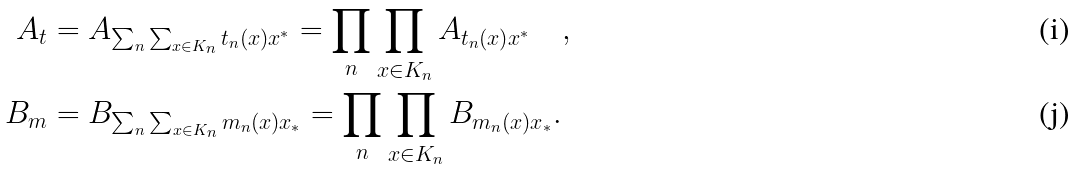Convert formula to latex. <formula><loc_0><loc_0><loc_500><loc_500>A _ { t } & = A _ { \sum _ { n } \sum _ { x \in K _ { n } } t _ { n } ( x ) x ^ { * } } = \prod _ { n } \prod _ { x \in K _ { n } } A _ { t _ { n } ( x ) x ^ { * } } \quad , \\ B _ { m } & = B _ { \sum _ { n } \sum _ { x \in K _ { n } } m _ { n } ( x ) x _ { * } } = \prod _ { n } \prod _ { x \in K _ { n } } B _ { m _ { n } ( x ) x _ { * } } .</formula> 